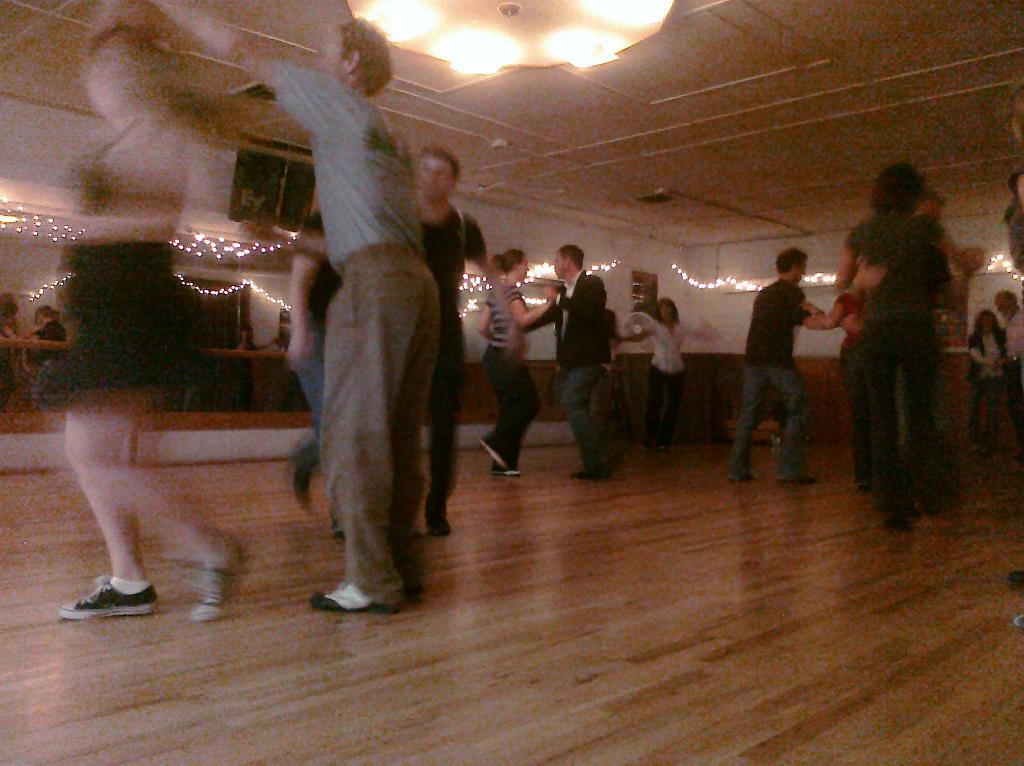How many people are in the image? There is a group of people in the image, but the exact number is not specified. What are the people doing in the image? The people are standing on the floor in the image. What can be seen in the background of the image? There is a group of lights in the background of the image. What appliance is present in the image? There is a table fan placed on a surface in the image. What type of pest can be seen crawling on the table fan in the image? There is no pest visible on the table fan in the image. Can you tell me the total cost of the items purchased by the people in the image? There is no receipt or indication of any purchases in the image. 